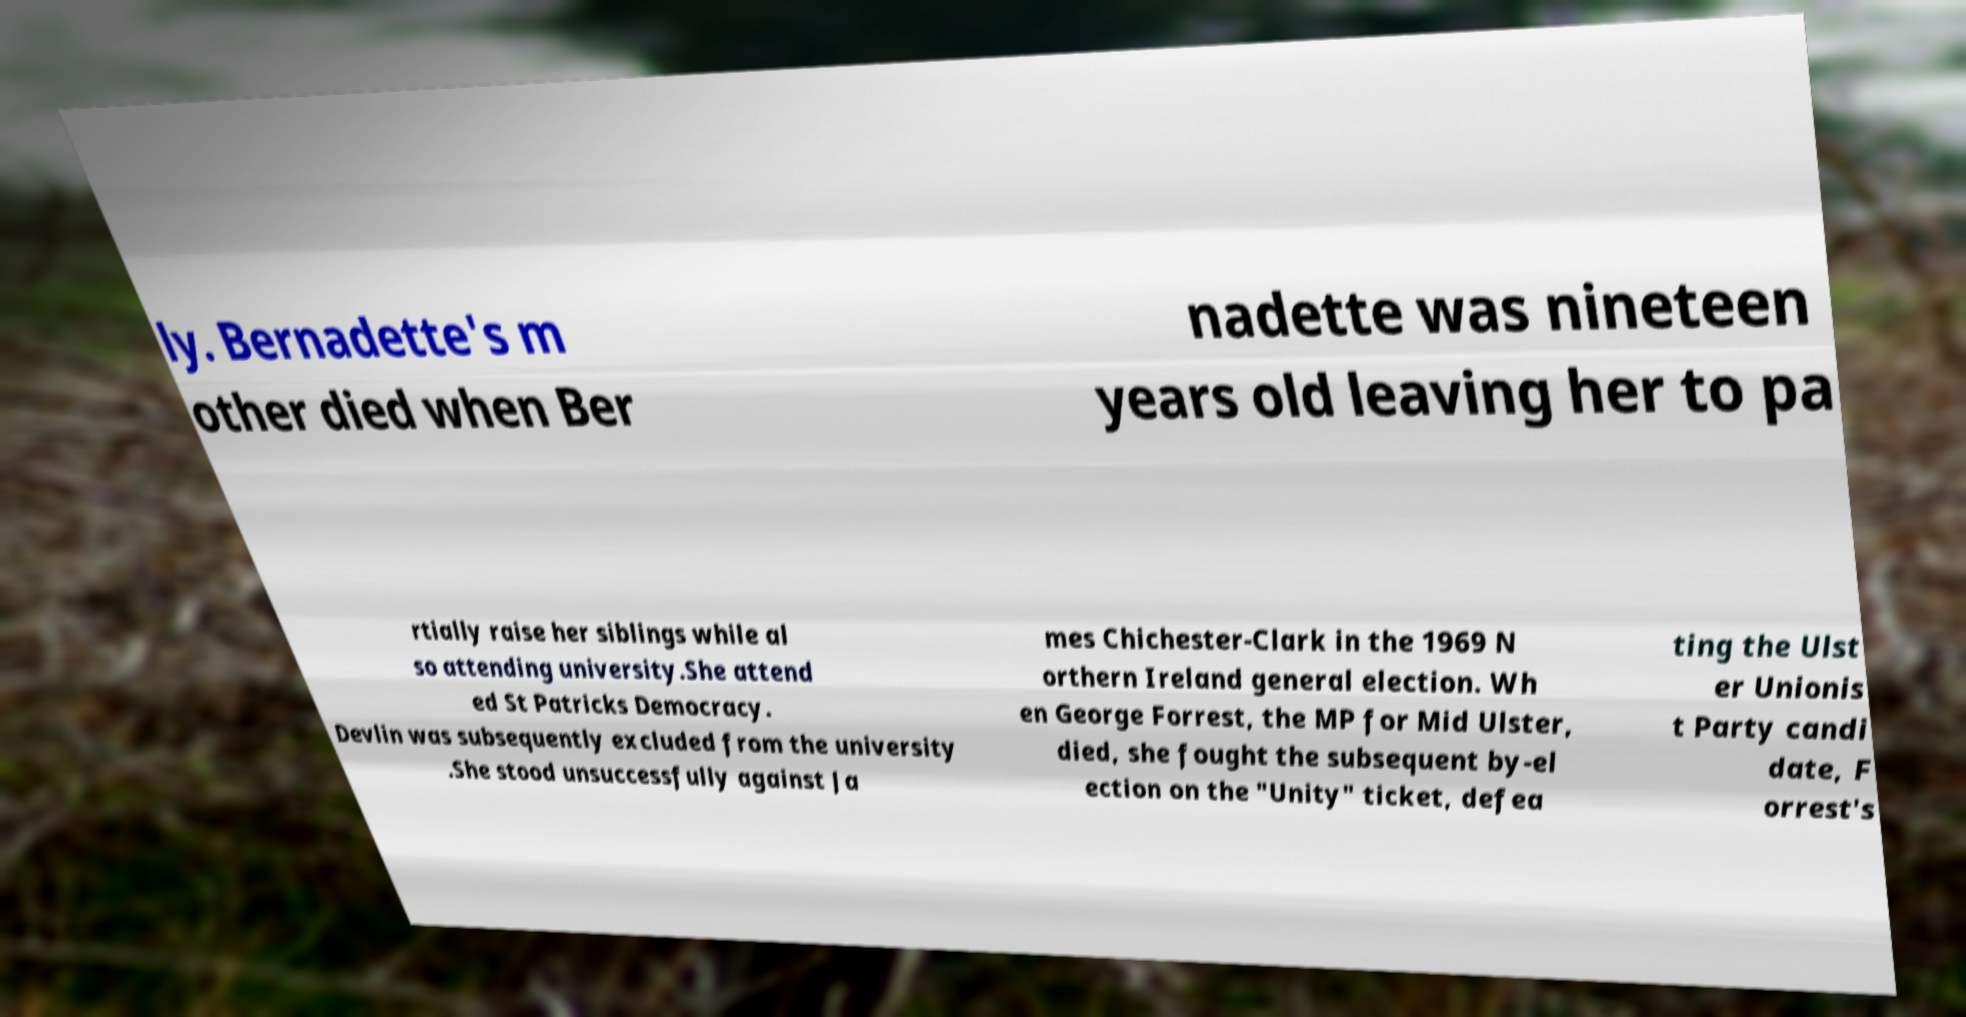Can you read and provide the text displayed in the image?This photo seems to have some interesting text. Can you extract and type it out for me? ly. Bernadette's m other died when Ber nadette was nineteen years old leaving her to pa rtially raise her siblings while al so attending university.She attend ed St Patricks Democracy. Devlin was subsequently excluded from the university .She stood unsuccessfully against Ja mes Chichester-Clark in the 1969 N orthern Ireland general election. Wh en George Forrest, the MP for Mid Ulster, died, she fought the subsequent by-el ection on the "Unity" ticket, defea ting the Ulst er Unionis t Party candi date, F orrest's 